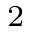<formula> <loc_0><loc_0><loc_500><loc_500>_ { 2 }</formula> 